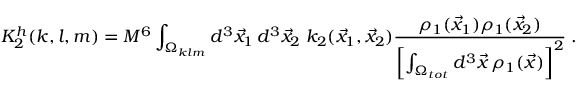Convert formula to latex. <formula><loc_0><loc_0><loc_500><loc_500>K _ { 2 } ^ { h } ( k , l , m ) = M ^ { 6 } \int _ { \Omega _ { k l m } } d ^ { 3 } \vec { x } _ { 1 } \, d ^ { 3 } \vec { x } _ { 2 } \, k _ { 2 } ( \vec { x } _ { 1 } , \vec { x } _ { 2 } ) { \frac { \rho _ { 1 } ( \vec { x } _ { 1 } ) \rho _ { 1 } ( \vec { x } _ { 2 } ) } { \left [ \int _ { \Omega _ { t o t } } d ^ { 3 } \vec { x } \, \rho _ { 1 } ( \vec { x } ) \right ] ^ { 2 } } } \, .</formula> 